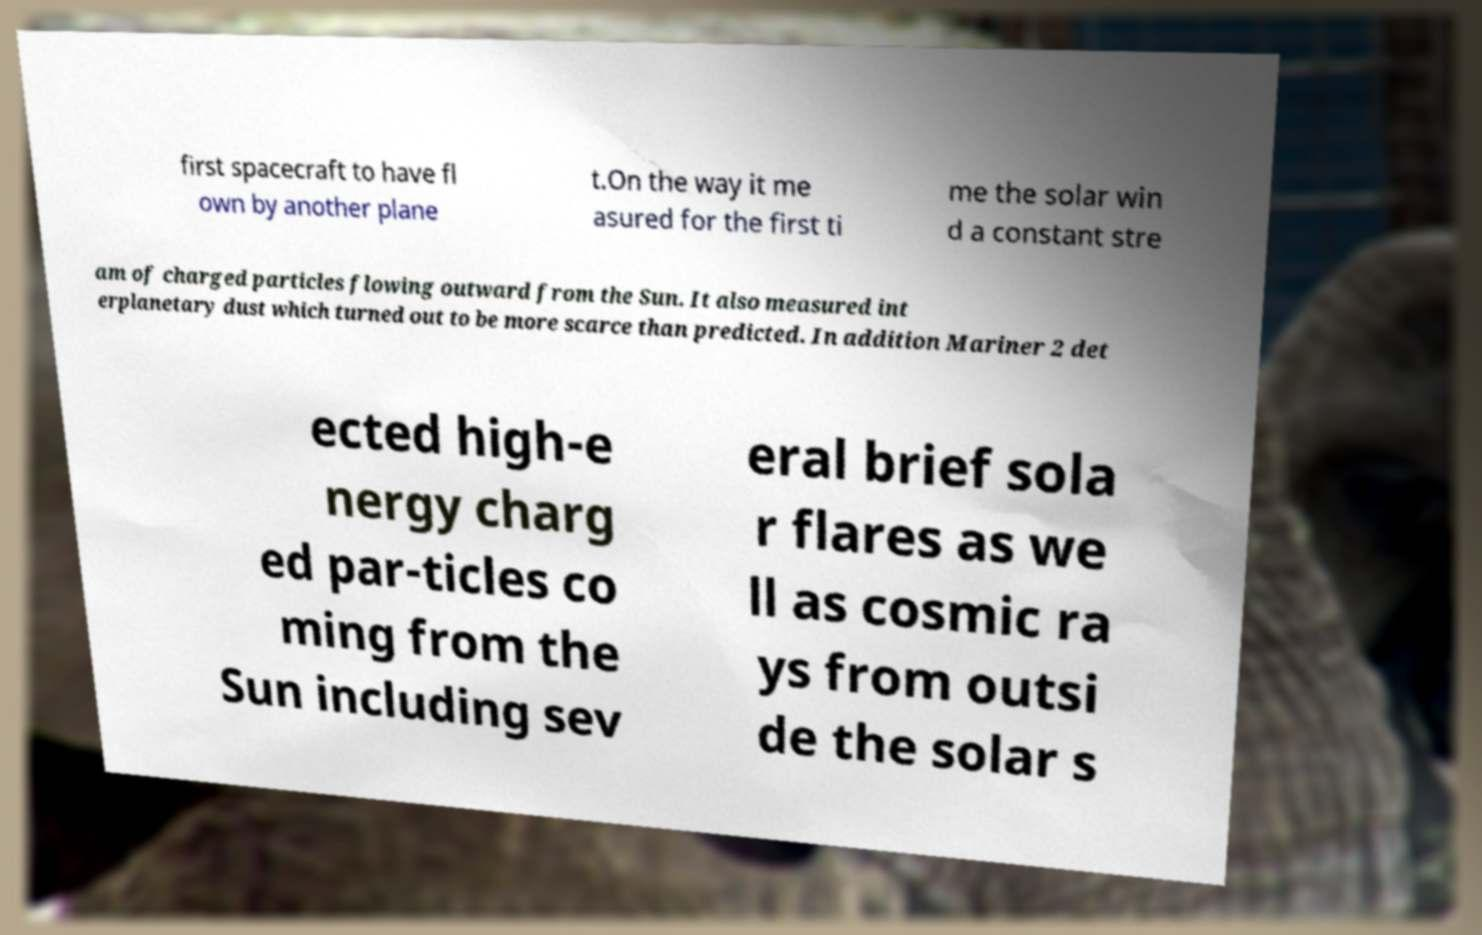Could you assist in decoding the text presented in this image and type it out clearly? first spacecraft to have fl own by another plane t.On the way it me asured for the first ti me the solar win d a constant stre am of charged particles flowing outward from the Sun. It also measured int erplanetary dust which turned out to be more scarce than predicted. In addition Mariner 2 det ected high-e nergy charg ed par-ticles co ming from the Sun including sev eral brief sola r flares as we ll as cosmic ra ys from outsi de the solar s 